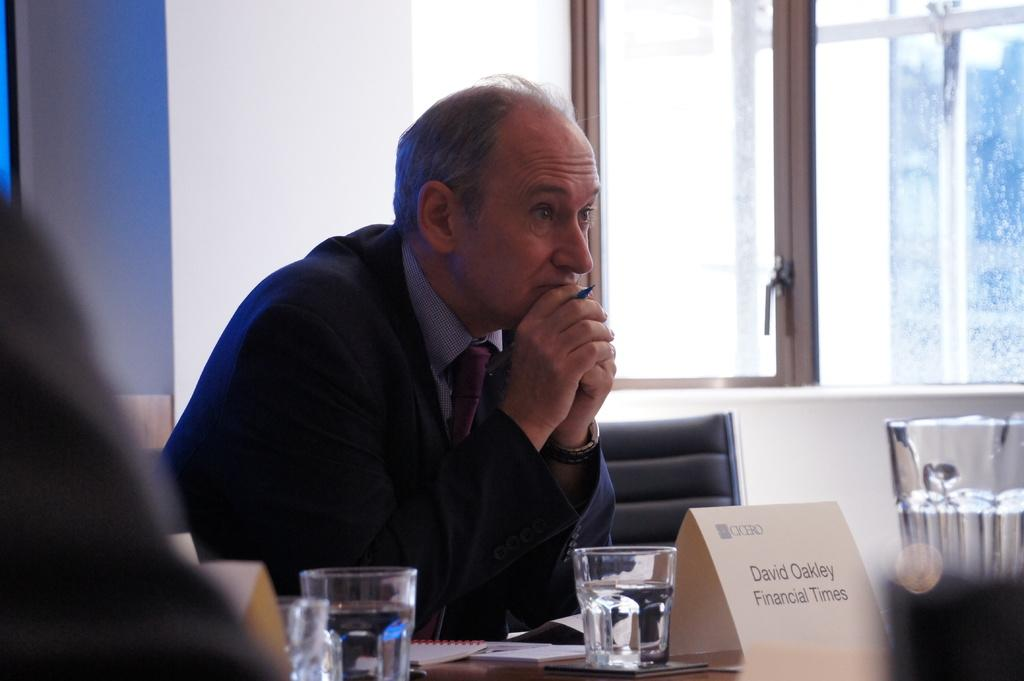<image>
Render a clear and concise summary of the photo. A man sits at a table, in front of him a name card claims he is from the finacial times. 